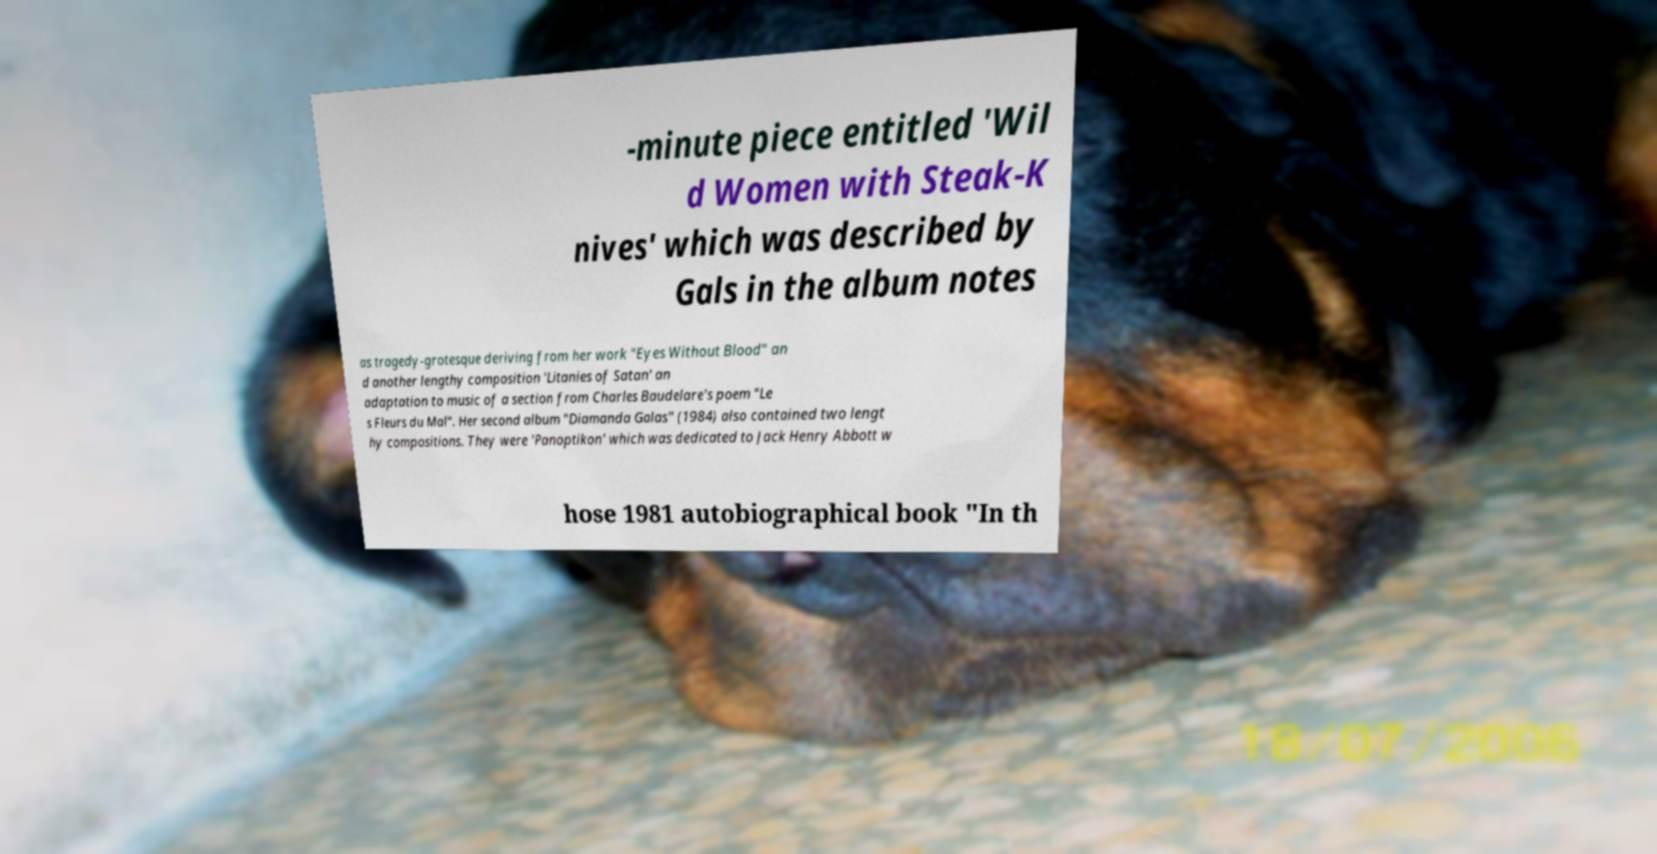Can you read and provide the text displayed in the image?This photo seems to have some interesting text. Can you extract and type it out for me? -minute piece entitled 'Wil d Women with Steak-K nives' which was described by Gals in the album notes as tragedy-grotesque deriving from her work "Eyes Without Blood" an d another lengthy composition 'Litanies of Satan' an adaptation to music of a section from Charles Baudelare's poem "Le s Fleurs du Mal". Her second album "Diamanda Galas" (1984) also contained two lengt hy compositions. They were 'Panoptikon' which was dedicated to Jack Henry Abbott w hose 1981 autobiographical book "In th 